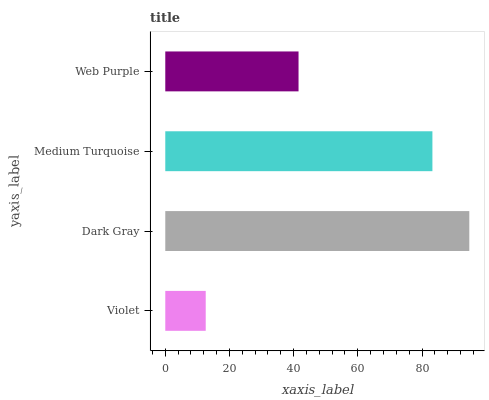Is Violet the minimum?
Answer yes or no. Yes. Is Dark Gray the maximum?
Answer yes or no. Yes. Is Medium Turquoise the minimum?
Answer yes or no. No. Is Medium Turquoise the maximum?
Answer yes or no. No. Is Dark Gray greater than Medium Turquoise?
Answer yes or no. Yes. Is Medium Turquoise less than Dark Gray?
Answer yes or no. Yes. Is Medium Turquoise greater than Dark Gray?
Answer yes or no. No. Is Dark Gray less than Medium Turquoise?
Answer yes or no. No. Is Medium Turquoise the high median?
Answer yes or no. Yes. Is Web Purple the low median?
Answer yes or no. Yes. Is Web Purple the high median?
Answer yes or no. No. Is Medium Turquoise the low median?
Answer yes or no. No. 